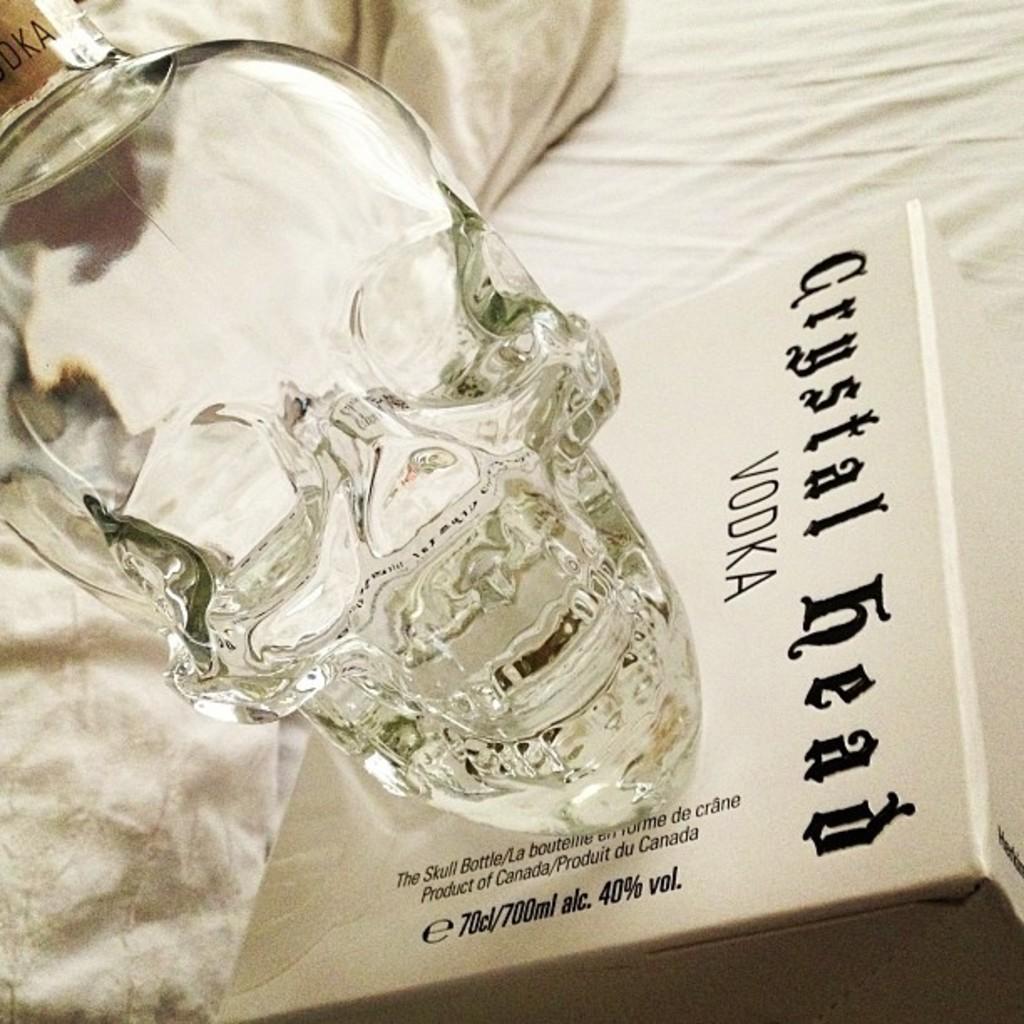What is the brand of vodka?
Your answer should be very brief. Crystal head. 